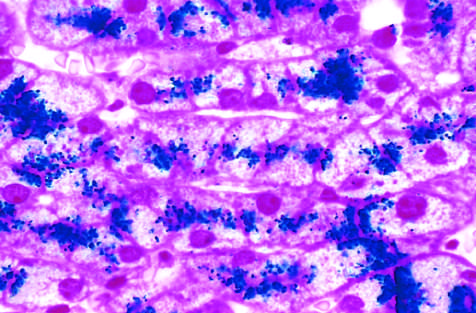what is called the prussian blue reaction?
Answer the question using a single word or phrase. A special staining process 